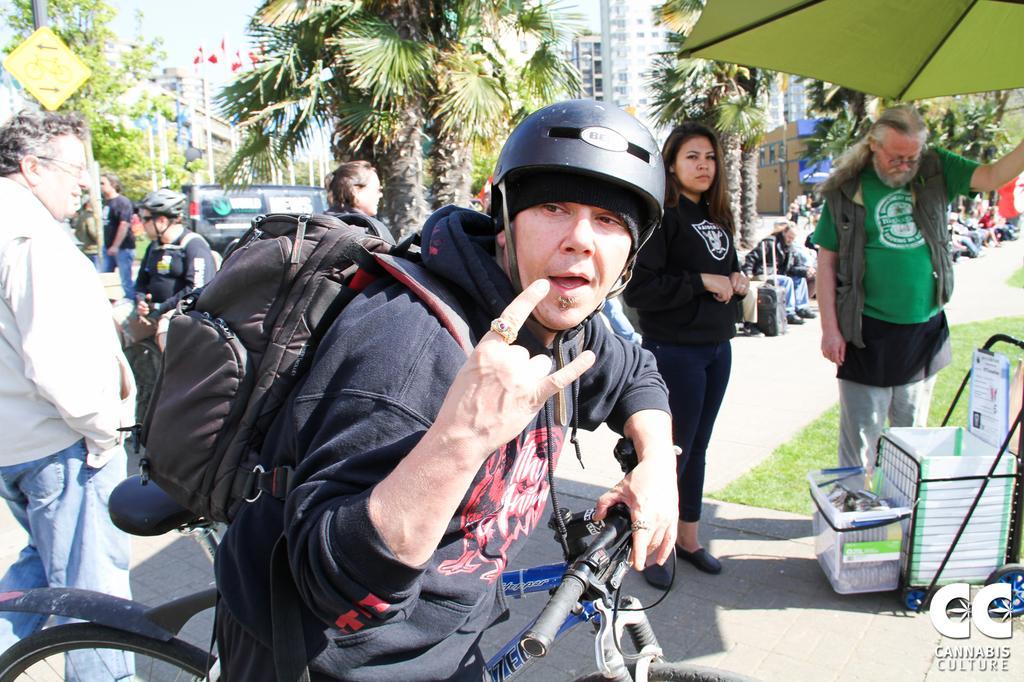In one or two sentences, can you explain what this image depicts? In this image I can see there are group of people among them the person in the front is wearing a helmet and a bag and riding a cycle. In the background of the image I can see there are few trees and buildings. 